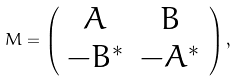Convert formula to latex. <formula><loc_0><loc_0><loc_500><loc_500>M = \left ( \begin{array} { c c } A & B \\ - B ^ { * } & - A ^ { * } \end{array} \right ) ,</formula> 